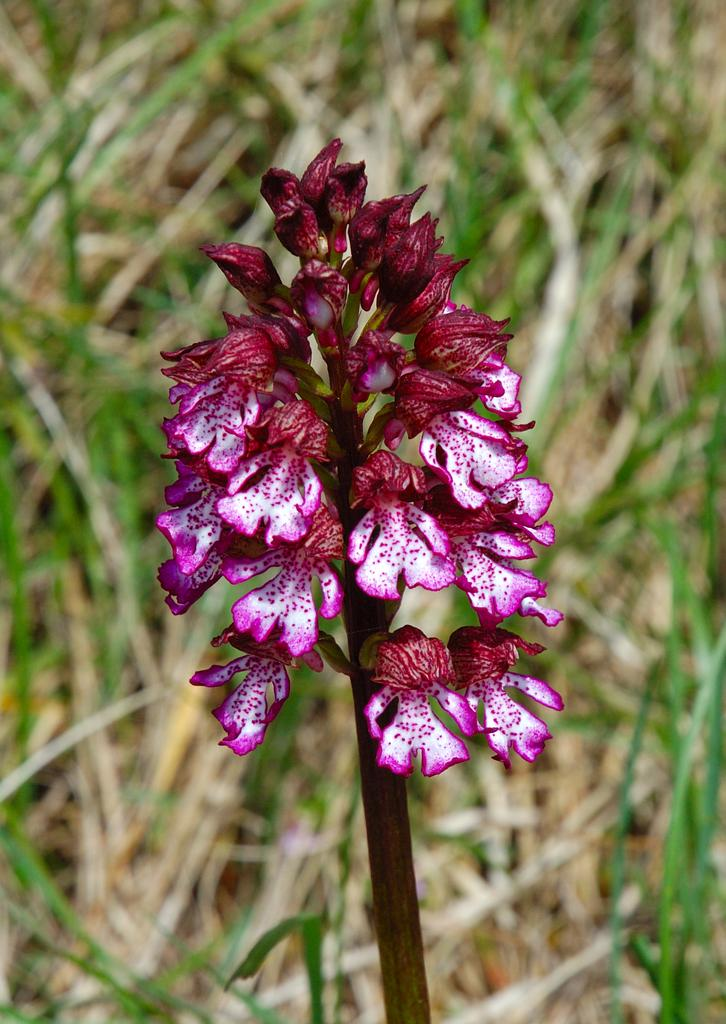What type of plants can be seen in the image? There are flowers in the image. What colors are the flowers? The flowers are in white and pink colors. What can be seen in the background of the image? There is grass visible in the background of the image. Can you see any caves in the image? There are no caves present in the image. Is there any water visible in the image? There is no water visible in the image. 